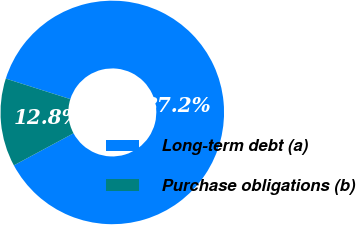Convert chart. <chart><loc_0><loc_0><loc_500><loc_500><pie_chart><fcel>Long-term debt (a)<fcel>Purchase obligations (b)<nl><fcel>87.25%<fcel>12.75%<nl></chart> 